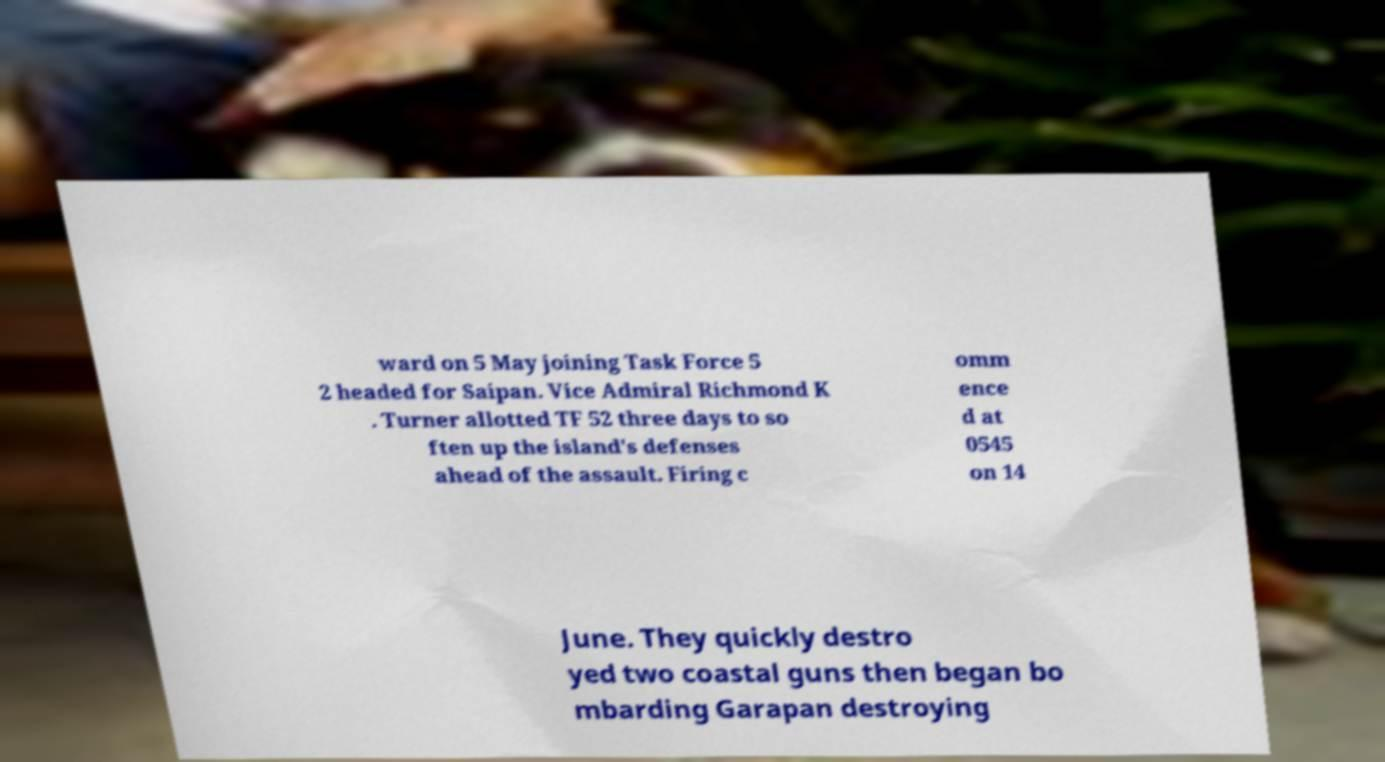Please read and relay the text visible in this image. What does it say? ward on 5 May joining Task Force 5 2 headed for Saipan. Vice Admiral Richmond K . Turner allotted TF 52 three days to so ften up the island's defenses ahead of the assault. Firing c omm ence d at 0545 on 14 June. They quickly destro yed two coastal guns then began bo mbarding Garapan destroying 